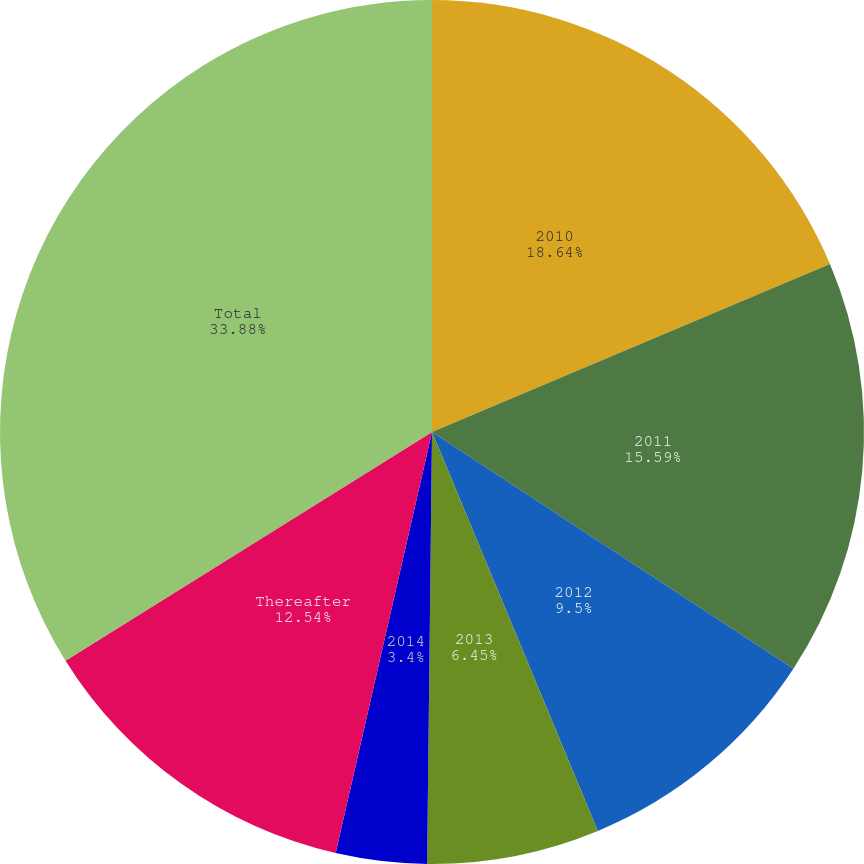<chart> <loc_0><loc_0><loc_500><loc_500><pie_chart><fcel>2010<fcel>2011<fcel>2012<fcel>2013<fcel>2014<fcel>Thereafter<fcel>Total<nl><fcel>18.64%<fcel>15.59%<fcel>9.5%<fcel>6.45%<fcel>3.4%<fcel>12.54%<fcel>33.88%<nl></chart> 